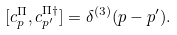<formula> <loc_0><loc_0><loc_500><loc_500>[ c ^ { \Pi } _ { p } , c _ { p ^ { \prime } } ^ { \Pi \dag } ] = \delta ^ { ( 3 ) } ( p - p ^ { \prime } ) .</formula> 